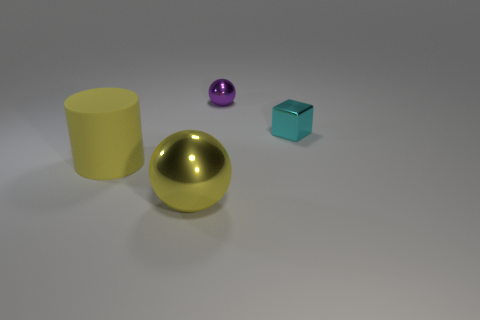How many tiny blocks are the same color as the matte thing?
Offer a very short reply. 0. The yellow object that is to the left of the metal sphere that is in front of the large yellow cylinder is what shape?
Keep it short and to the point. Cylinder. Is there another large cyan metallic object that has the same shape as the cyan metal object?
Keep it short and to the point. No. There is a large shiny sphere; is it the same color as the sphere behind the big yellow rubber cylinder?
Provide a short and direct response. No. What size is the sphere that is the same color as the matte cylinder?
Provide a short and direct response. Large. Is there another object of the same size as the rubber thing?
Make the answer very short. Yes. Is the yellow cylinder made of the same material as the yellow ball in front of the big cylinder?
Keep it short and to the point. No. Is the number of small cyan metal objects greater than the number of small yellow matte spheres?
Your response must be concise. Yes. How many cylinders are metal things or tiny purple metal things?
Provide a short and direct response. 0. What is the color of the big ball?
Your answer should be very brief. Yellow. 